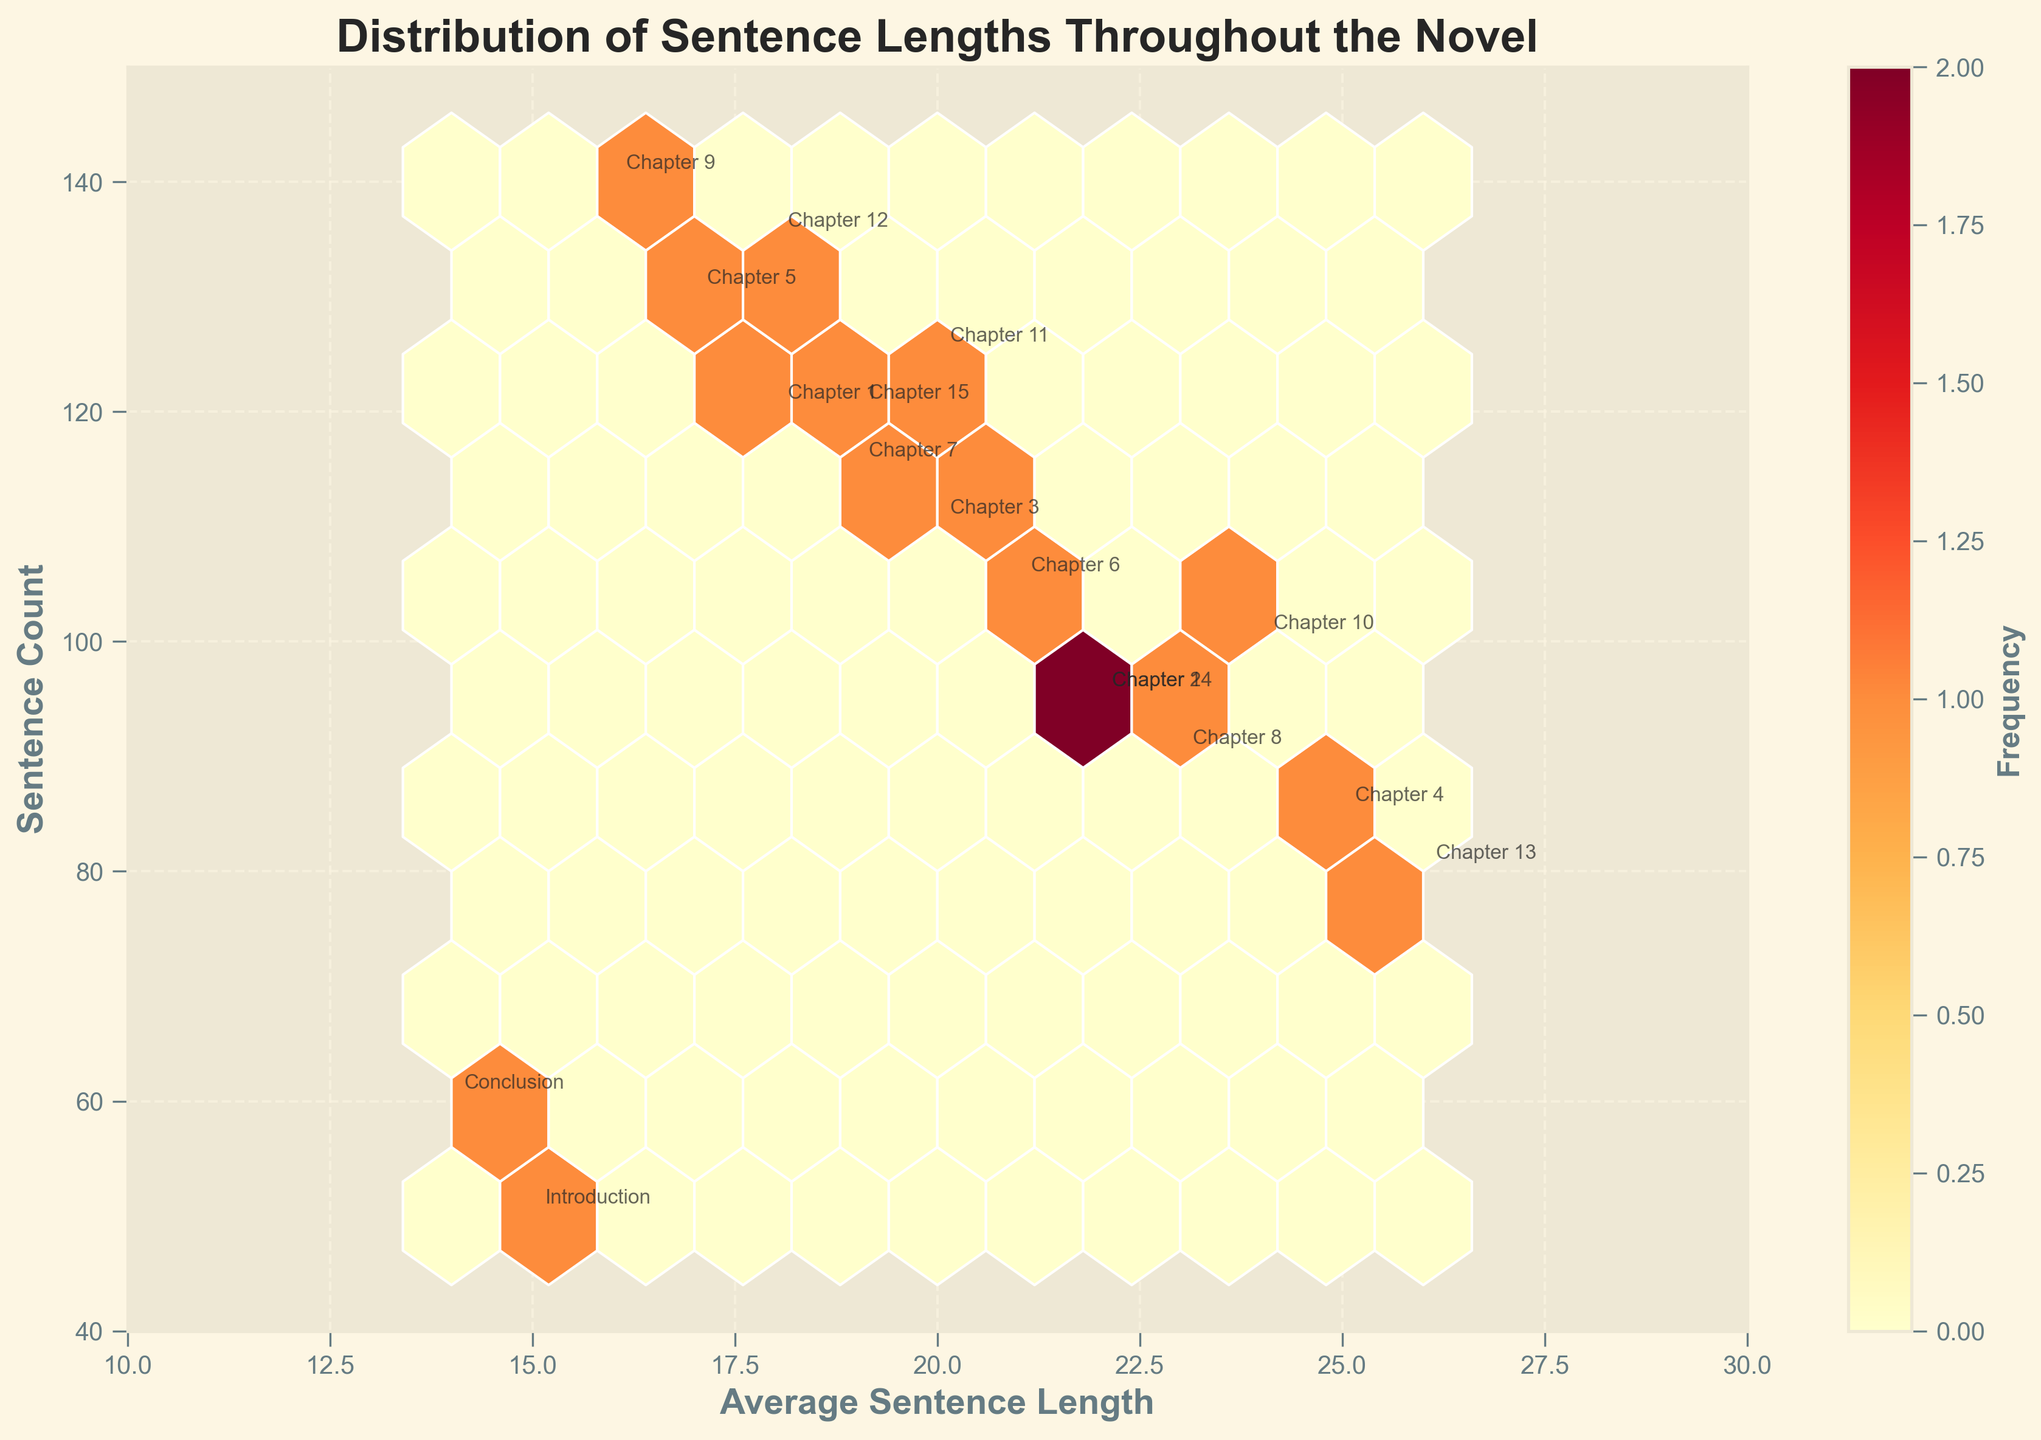How many data points are represented in the hexbin plot? By counting each chapter listed in the data, we find that there are 17 data points, from "Introduction" to "Conclusion".
Answer: 17 What is the title of the hexbin plot? The title is clearly stated above the plot.
Answer: Distribution of Sentence Lengths Throughout the Novel Which axis represents the average sentence length? The label under the x-axis indicates it represents the average sentence length.
Answer: x-axis What color scale is used in the plot? Observing the color bar on the plot, we see it ranges from yellow to red.
Answer: Yellow to Red What is the average sentence length with the highest sentence count? "Chapter 9" has the highest sentence count of 140 and an average sentence length of 16.
Answer: 16 Which chapter has the shortest average sentence length? The "Conclusion" chapter is marked on the lowest point of the x-axis (14).
Answer: Conclusion Which chapter has both the smallest average sentence length and the lowest sentence count? By referring to labeled points, the "Conclusion" chapter has an average sentence length of 14 and the lowest sentence count of 60.
Answer: Conclusion What is the range of average sentence lengths in the figure? By looking at the axes limits and the lowest and highest data points, the x-axis ranges from 10 to 30.
Answer: 10 to 30 Which region on the plot has the highest frequency of data points? The color bar indicates the density; the darkest (deep red) region is approximately around an average sentence length of 18 and a sentence count of 120.
Answer: Average sentence length 18, sentence count 120 Comparing Chapter 1 and Chapter 10, which has a higher average sentence length? Chapter 10 has an average sentence length of 24, which is higher than Chapter 1’s average sentence length of 18.
Answer: Chapter 10 Comparing Chapter 5 and Chapter 13, which chapter has more sentences? Chapter 5 has a sentence count of 130, compared to Chapter 13’s count of 80.
Answer: Chapter 5 